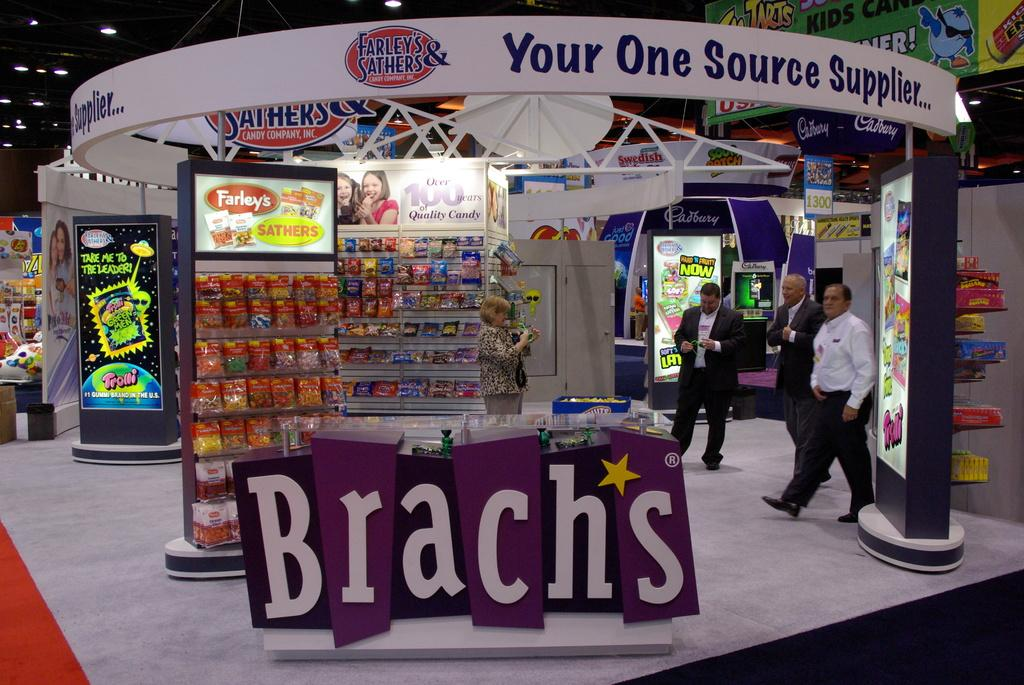<image>
Write a terse but informative summary of the picture. A display with Brachs candies and Farley candy with a banner that says your one source supplier 3 men are standing there having their picture taken by a woman 